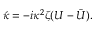Convert formula to latex. <formula><loc_0><loc_0><loc_500><loc_500>\acute { \kappa } = - i \kappa ^ { 2 } \zeta ( U - \bar { U } ) .</formula> 